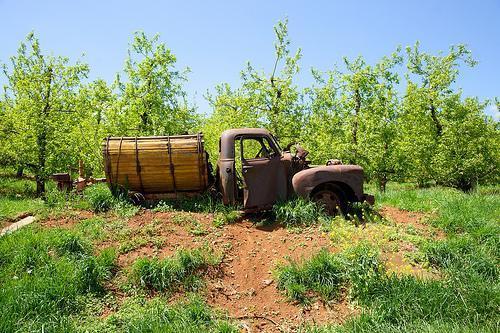How many vehicles are there?
Give a very brief answer. 1. 